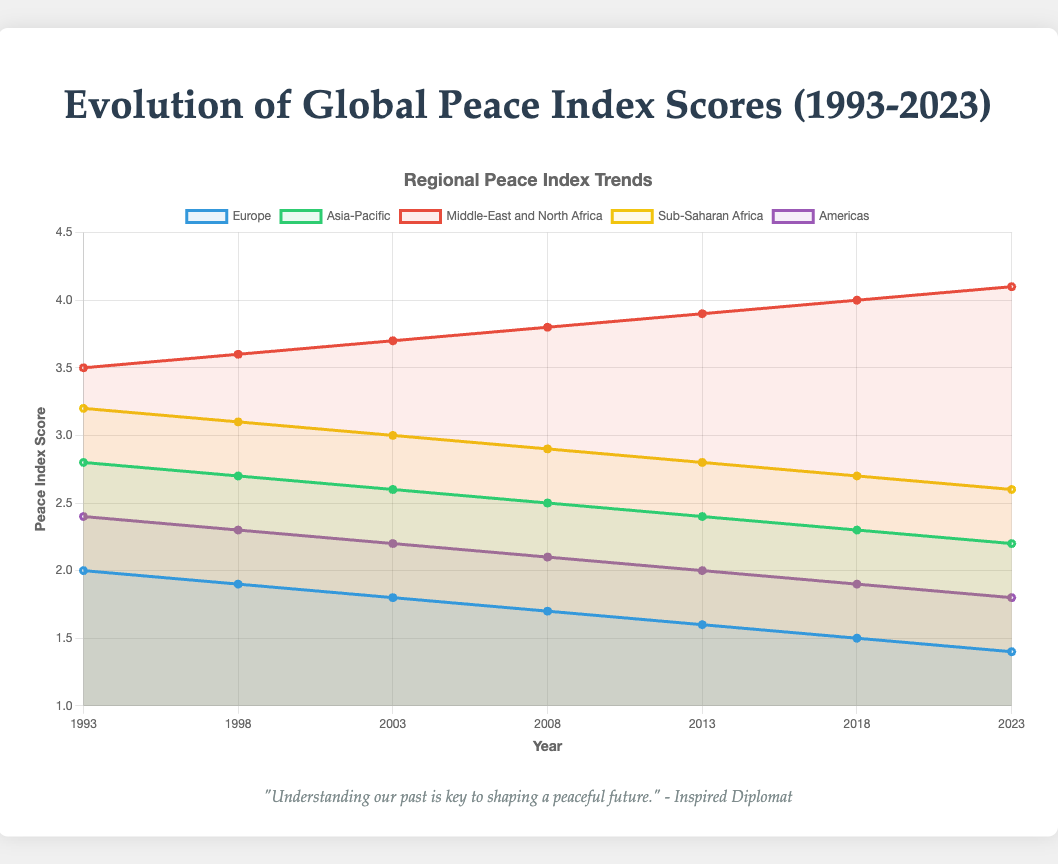What is the overall trend of the peace index score for Europe from 1993 to 2023? The peace index score for Europe shows a decreasing trend from 2.0 in 1993 to 1.4 in 2023. Each data point for Europe gradually declines over the years.
Answer: Decreasing Which region had the highest peace index score in 2023? In 2023, the Middle-East and North Africa had the highest peace index score of 4.1, which is the highest value among all regions shown on the figure.
Answer: Middle-East and North Africa Compare the peace index score of Asia-Pacific and Sub-Saharan Africa in 2008. Which region had a better score? In 2008, the peace index score for Asia-Pacific was 2.5 and for Sub-Saharan Africa it was 2.9. A lower score indicates a better peace index, so Asia-Pacific had a better score.
Answer: Asia-Pacific What is the difference in the peace index score of the Americas between 1993 and 2023? The peace index score for the Americas in 1993 was 2.4 and in 2023 it was 1.8. The difference is calculated as 2.4 - 1.8 = 0.6.
Answer: 0.6 How did the peace index score for Middle-East and North Africa change from 1993 to 2023? The peace index score for Middle-East and North Africa increased from 3.5 in 1993 to 4.1 in 2023.
Answer: Increased Which region showed the most significant improvement in peace index score over the three decades? Europe showed the most significant improvement with a score decrease from 2.0 in 1993 to 1.4 in 2023, a reduction of 0.6 points.
Answer: Europe What was the average peace index score of Sub-Saharan Africa over the periods 1993, 1998, and 2003? The peace index scores for Sub-Saharan Africa are 3.2 (1993), 3.1 (1998), and 3.0 (2003). The average is calculated as (3.2 + 3.1 + 3.0) / 3 = 3.1.
Answer: 3.1 Which region had the least variation in peace index scores from 1993 to 2023? Europe had the least variation as its scores ranged from 2.0 in 1993 to 1.4 in 2023. The standard deviation seems lower compared to other regions where scores changed more drastically.
Answer: Europe 